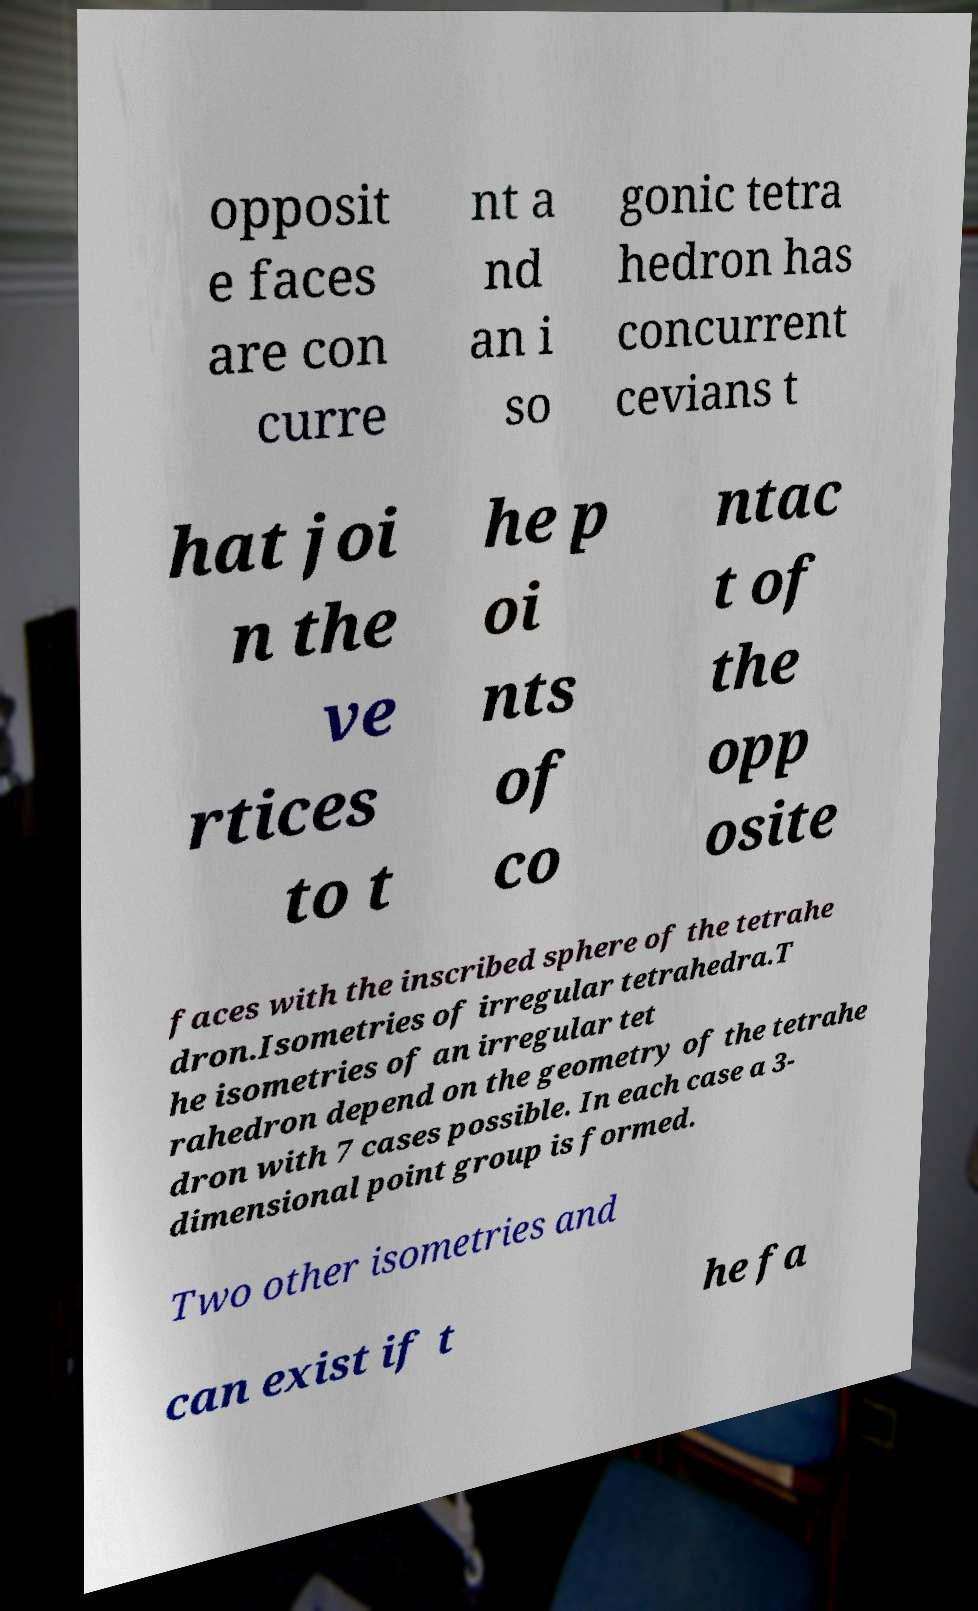Could you extract and type out the text from this image? opposit e faces are con curre nt a nd an i so gonic tetra hedron has concurrent cevians t hat joi n the ve rtices to t he p oi nts of co ntac t of the opp osite faces with the inscribed sphere of the tetrahe dron.Isometries of irregular tetrahedra.T he isometries of an irregular tet rahedron depend on the geometry of the tetrahe dron with 7 cases possible. In each case a 3- dimensional point group is formed. Two other isometries and can exist if t he fa 